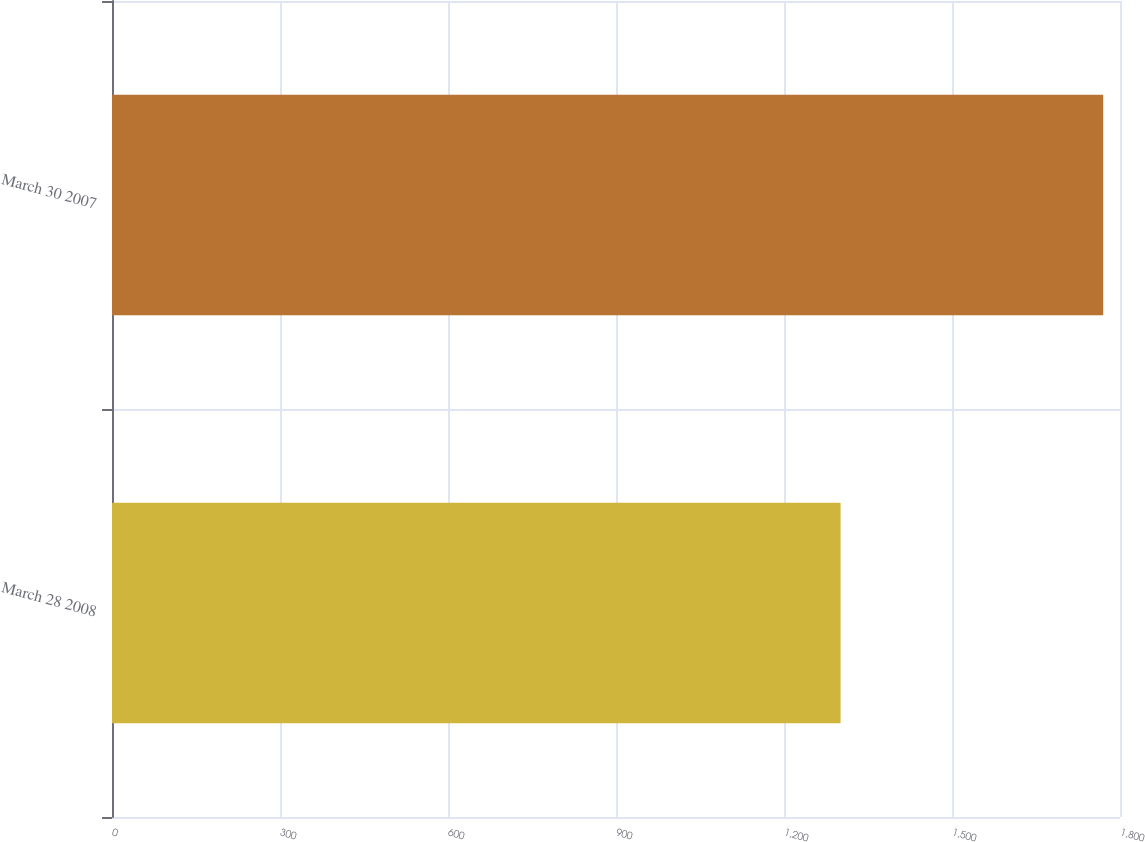Convert chart to OTSL. <chart><loc_0><loc_0><loc_500><loc_500><bar_chart><fcel>March 28 2008<fcel>March 30 2007<nl><fcel>1301<fcel>1770<nl></chart> 